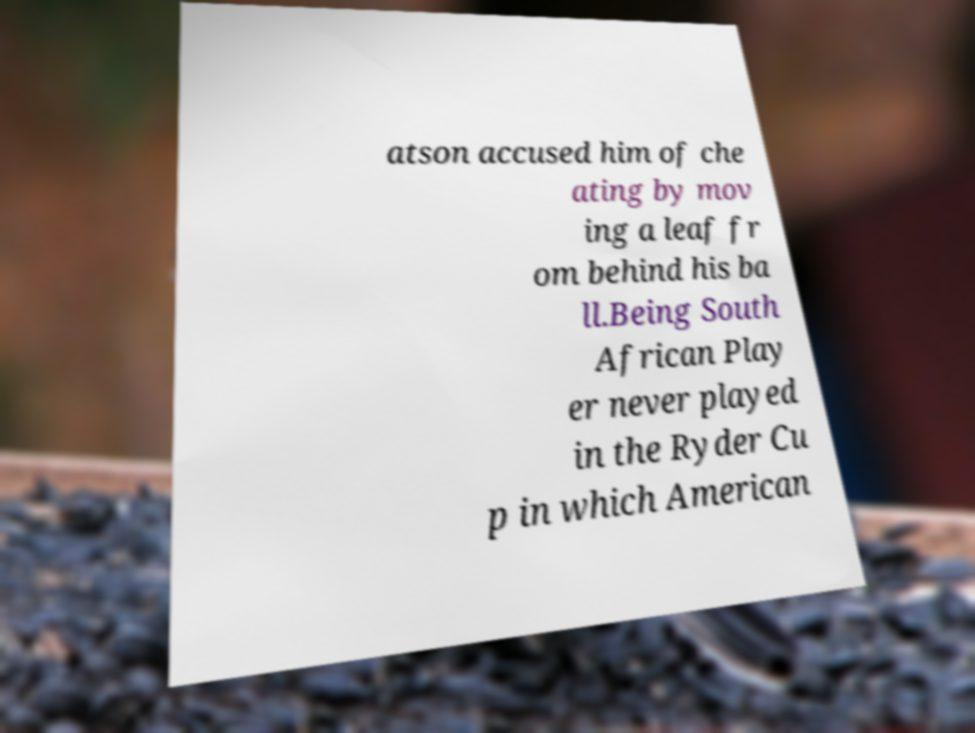Can you read and provide the text displayed in the image?This photo seems to have some interesting text. Can you extract and type it out for me? atson accused him of che ating by mov ing a leaf fr om behind his ba ll.Being South African Play er never played in the Ryder Cu p in which American 